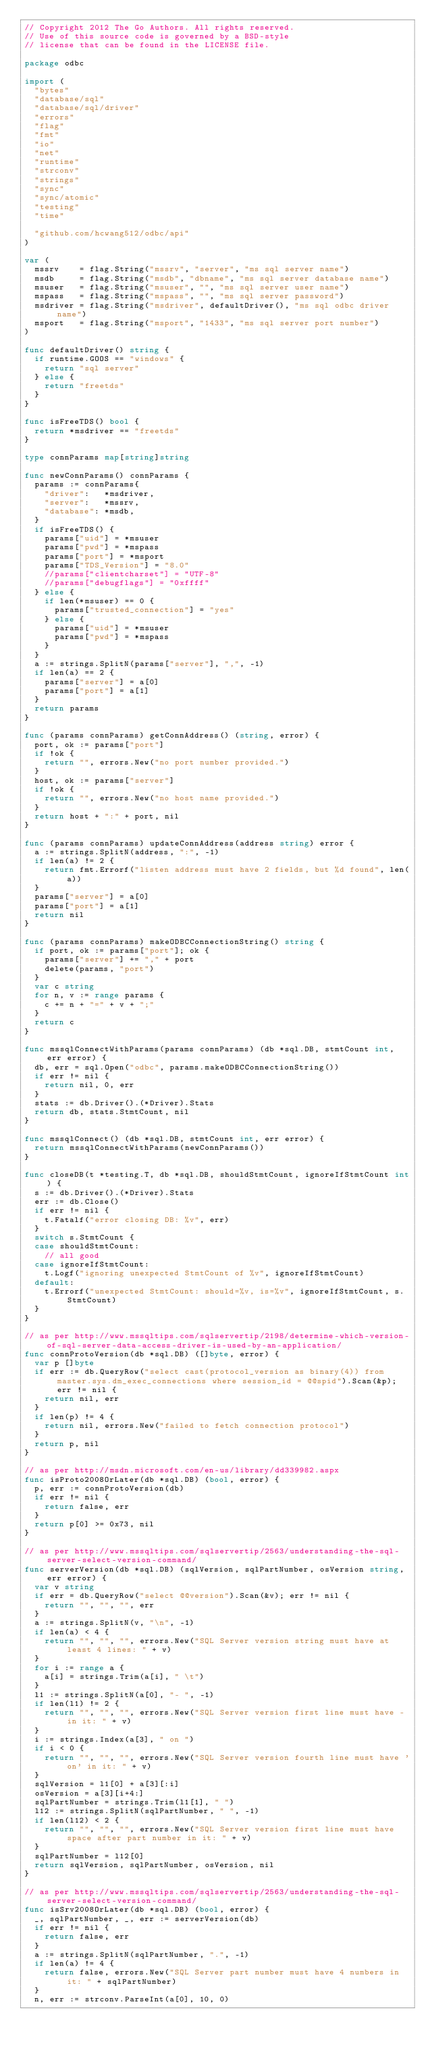<code> <loc_0><loc_0><loc_500><loc_500><_Go_>// Copyright 2012 The Go Authors. All rights reserved.
// Use of this source code is governed by a BSD-style
// license that can be found in the LICENSE file.

package odbc

import (
	"bytes"
	"database/sql"
	"database/sql/driver"
	"errors"
	"flag"
	"fmt"
	"io"
	"net"
	"runtime"
	"strconv"
	"strings"
	"sync"
	"sync/atomic"
	"testing"
	"time"

	"github.com/hcwang512/odbc/api"
)

var (
	mssrv    = flag.String("mssrv", "server", "ms sql server name")
	msdb     = flag.String("msdb", "dbname", "ms sql server database name")
	msuser   = flag.String("msuser", "", "ms sql server user name")
	mspass   = flag.String("mspass", "", "ms sql server password")
	msdriver = flag.String("msdriver", defaultDriver(), "ms sql odbc driver name")
	msport   = flag.String("msport", "1433", "ms sql server port number")
)

func defaultDriver() string {
	if runtime.GOOS == "windows" {
		return "sql server"
	} else {
		return "freetds"
	}
}

func isFreeTDS() bool {
	return *msdriver == "freetds"
}

type connParams map[string]string

func newConnParams() connParams {
	params := connParams{
		"driver":   *msdriver,
		"server":   *mssrv,
		"database": *msdb,
	}
	if isFreeTDS() {
		params["uid"] = *msuser
		params["pwd"] = *mspass
		params["port"] = *msport
		params["TDS_Version"] = "8.0"
		//params["clientcharset"] = "UTF-8"
		//params["debugflags"] = "0xffff"
	} else {
		if len(*msuser) == 0 {
			params["trusted_connection"] = "yes"
		} else {
			params["uid"] = *msuser
			params["pwd"] = *mspass
		}
	}
	a := strings.SplitN(params["server"], ",", -1)
	if len(a) == 2 {
		params["server"] = a[0]
		params["port"] = a[1]
	}
	return params
}

func (params connParams) getConnAddress() (string, error) {
	port, ok := params["port"]
	if !ok {
		return "", errors.New("no port number provided.")
	}
	host, ok := params["server"]
	if !ok {
		return "", errors.New("no host name provided.")
	}
	return host + ":" + port, nil
}

func (params connParams) updateConnAddress(address string) error {
	a := strings.SplitN(address, ":", -1)
	if len(a) != 2 {
		return fmt.Errorf("listen address must have 2 fields, but %d found", len(a))
	}
	params["server"] = a[0]
	params["port"] = a[1]
	return nil
}

func (params connParams) makeODBCConnectionString() string {
	if port, ok := params["port"]; ok {
		params["server"] += "," + port
		delete(params, "port")
	}
	var c string
	for n, v := range params {
		c += n + "=" + v + ";"
	}
	return c
}

func mssqlConnectWithParams(params connParams) (db *sql.DB, stmtCount int, err error) {
	db, err = sql.Open("odbc", params.makeODBCConnectionString())
	if err != nil {
		return nil, 0, err
	}
	stats := db.Driver().(*Driver).Stats
	return db, stats.StmtCount, nil
}

func mssqlConnect() (db *sql.DB, stmtCount int, err error) {
	return mssqlConnectWithParams(newConnParams())
}

func closeDB(t *testing.T, db *sql.DB, shouldStmtCount, ignoreIfStmtCount int) {
	s := db.Driver().(*Driver).Stats
	err := db.Close()
	if err != nil {
		t.Fatalf("error closing DB: %v", err)
	}
	switch s.StmtCount {
	case shouldStmtCount:
		// all good
	case ignoreIfStmtCount:
		t.Logf("ignoring unexpected StmtCount of %v", ignoreIfStmtCount)
	default:
		t.Errorf("unexpected StmtCount: should=%v, is=%v", ignoreIfStmtCount, s.StmtCount)
	}
}

// as per http://www.mssqltips.com/sqlservertip/2198/determine-which-version-of-sql-server-data-access-driver-is-used-by-an-application/
func connProtoVersion(db *sql.DB) ([]byte, error) {
	var p []byte
	if err := db.QueryRow("select cast(protocol_version as binary(4)) from master.sys.dm_exec_connections where session_id = @@spid").Scan(&p); err != nil {
		return nil, err
	}
	if len(p) != 4 {
		return nil, errors.New("failed to fetch connection protocol")
	}
	return p, nil
}

// as per http://msdn.microsoft.com/en-us/library/dd339982.aspx
func isProto2008OrLater(db *sql.DB) (bool, error) {
	p, err := connProtoVersion(db)
	if err != nil {
		return false, err
	}
	return p[0] >= 0x73, nil
}

// as per http://www.mssqltips.com/sqlservertip/2563/understanding-the-sql-server-select-version-command/
func serverVersion(db *sql.DB) (sqlVersion, sqlPartNumber, osVersion string, err error) {
	var v string
	if err = db.QueryRow("select @@version").Scan(&v); err != nil {
		return "", "", "", err
	}
	a := strings.SplitN(v, "\n", -1)
	if len(a) < 4 {
		return "", "", "", errors.New("SQL Server version string must have at least 4 lines: " + v)
	}
	for i := range a {
		a[i] = strings.Trim(a[i], " \t")
	}
	l1 := strings.SplitN(a[0], "- ", -1)
	if len(l1) != 2 {
		return "", "", "", errors.New("SQL Server version first line must have - in it: " + v)
	}
	i := strings.Index(a[3], " on ")
	if i < 0 {
		return "", "", "", errors.New("SQL Server version fourth line must have 'on' in it: " + v)
	}
	sqlVersion = l1[0] + a[3][:i]
	osVersion = a[3][i+4:]
	sqlPartNumber = strings.Trim(l1[1], " ")
	l12 := strings.SplitN(sqlPartNumber, " ", -1)
	if len(l12) < 2 {
		return "", "", "", errors.New("SQL Server version first line must have space after part number in it: " + v)
	}
	sqlPartNumber = l12[0]
	return sqlVersion, sqlPartNumber, osVersion, nil
}

// as per http://www.mssqltips.com/sqlservertip/2563/understanding-the-sql-server-select-version-command/
func isSrv2008OrLater(db *sql.DB) (bool, error) {
	_, sqlPartNumber, _, err := serverVersion(db)
	if err != nil {
		return false, err
	}
	a := strings.SplitN(sqlPartNumber, ".", -1)
	if len(a) != 4 {
		return false, errors.New("SQL Server part number must have 4 numbers in it: " + sqlPartNumber)
	}
	n, err := strconv.ParseInt(a[0], 10, 0)</code> 